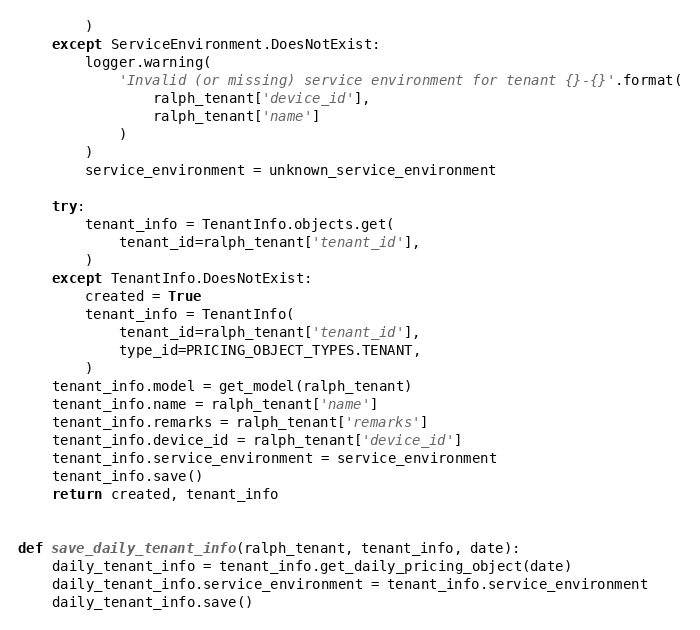<code> <loc_0><loc_0><loc_500><loc_500><_Python_>        )
    except ServiceEnvironment.DoesNotExist:
        logger.warning(
            'Invalid (or missing) service environment for tenant {}-{}'.format(
                ralph_tenant['device_id'],
                ralph_tenant['name']
            )
        )
        service_environment = unknown_service_environment

    try:
        tenant_info = TenantInfo.objects.get(
            tenant_id=ralph_tenant['tenant_id'],
        )
    except TenantInfo.DoesNotExist:
        created = True
        tenant_info = TenantInfo(
            tenant_id=ralph_tenant['tenant_id'],
            type_id=PRICING_OBJECT_TYPES.TENANT,
        )
    tenant_info.model = get_model(ralph_tenant)
    tenant_info.name = ralph_tenant['name']
    tenant_info.remarks = ralph_tenant['remarks']
    tenant_info.device_id = ralph_tenant['device_id']
    tenant_info.service_environment = service_environment
    tenant_info.save()
    return created, tenant_info


def save_daily_tenant_info(ralph_tenant, tenant_info, date):
    daily_tenant_info = tenant_info.get_daily_pricing_object(date)
    daily_tenant_info.service_environment = tenant_info.service_environment
    daily_tenant_info.save()</code> 